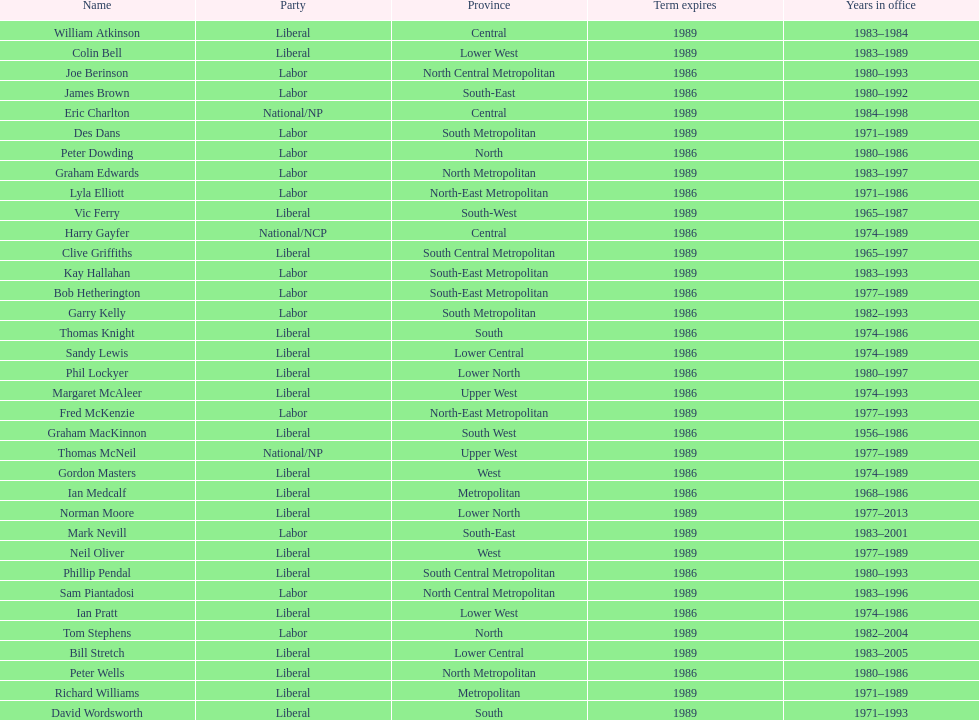What is the count of members with terms concluding in 1989? 9. 